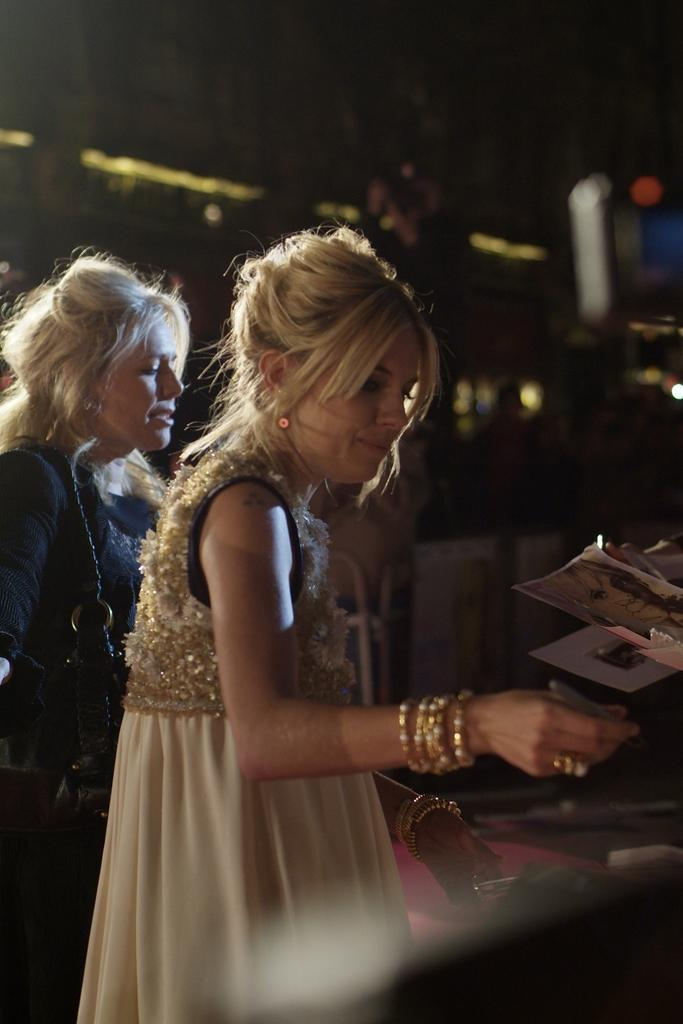How many people are in the image? There are two women standing in the image. What is one of the women holding in their hand? A person is holding papers in their hand. What can be seen in the background of the image? There is a building in the background of the image. What type of lettuce is being used to decorate the cake in the image? There is no cake or lettuce present in the image. How steep is the slope in the image? There is no slope present in the image. 